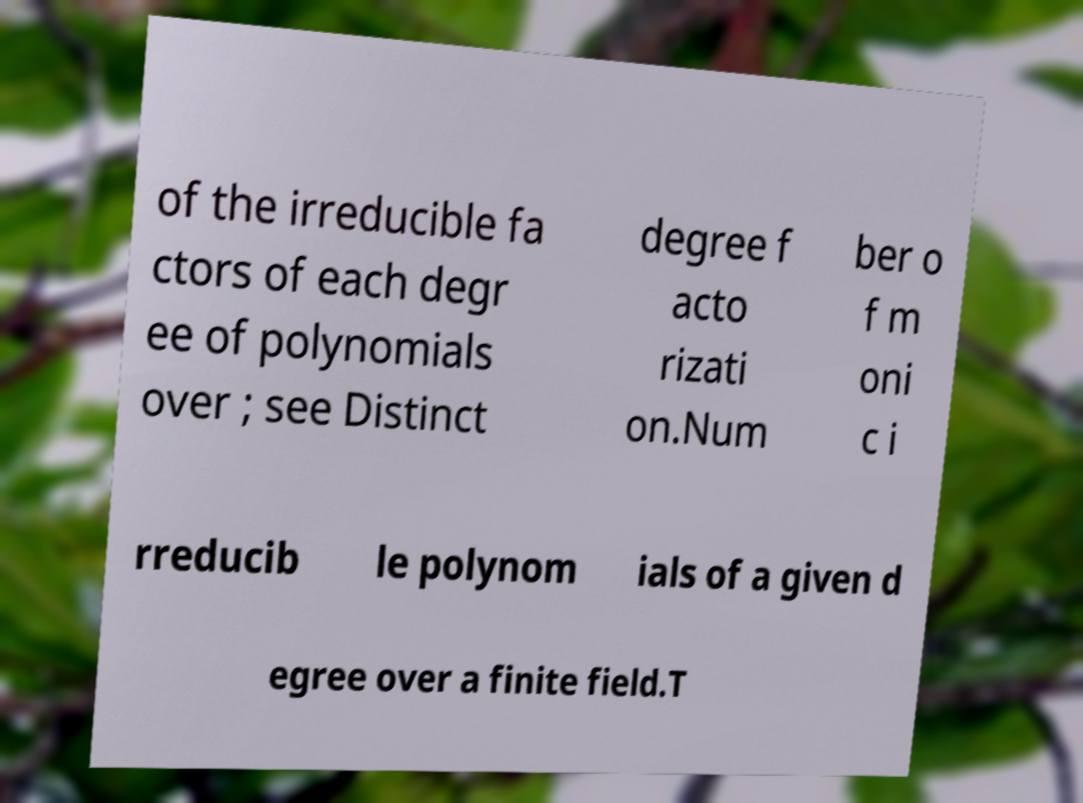For documentation purposes, I need the text within this image transcribed. Could you provide that? of the irreducible fa ctors of each degr ee of polynomials over ; see Distinct degree f acto rizati on.Num ber o f m oni c i rreducib le polynom ials of a given d egree over a finite field.T 